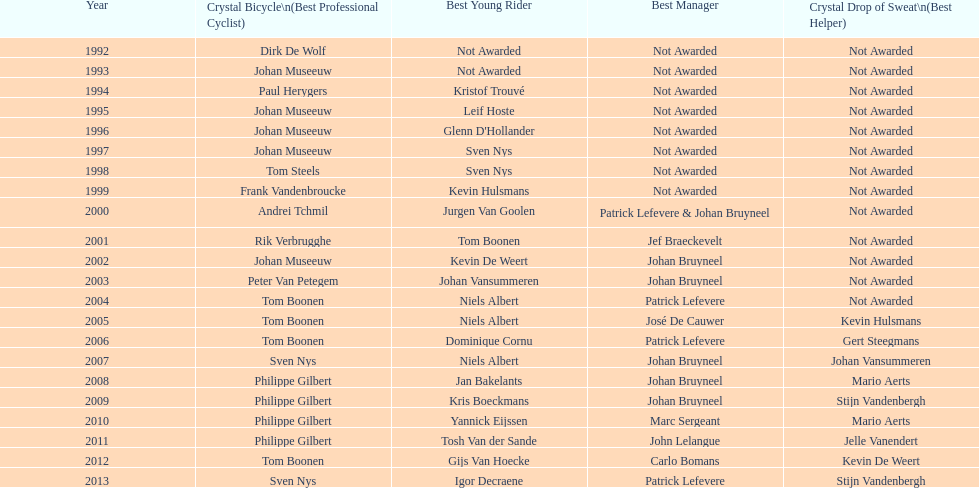Who has the highest number of successive crystal bicycle victories? Philippe Gilbert. 